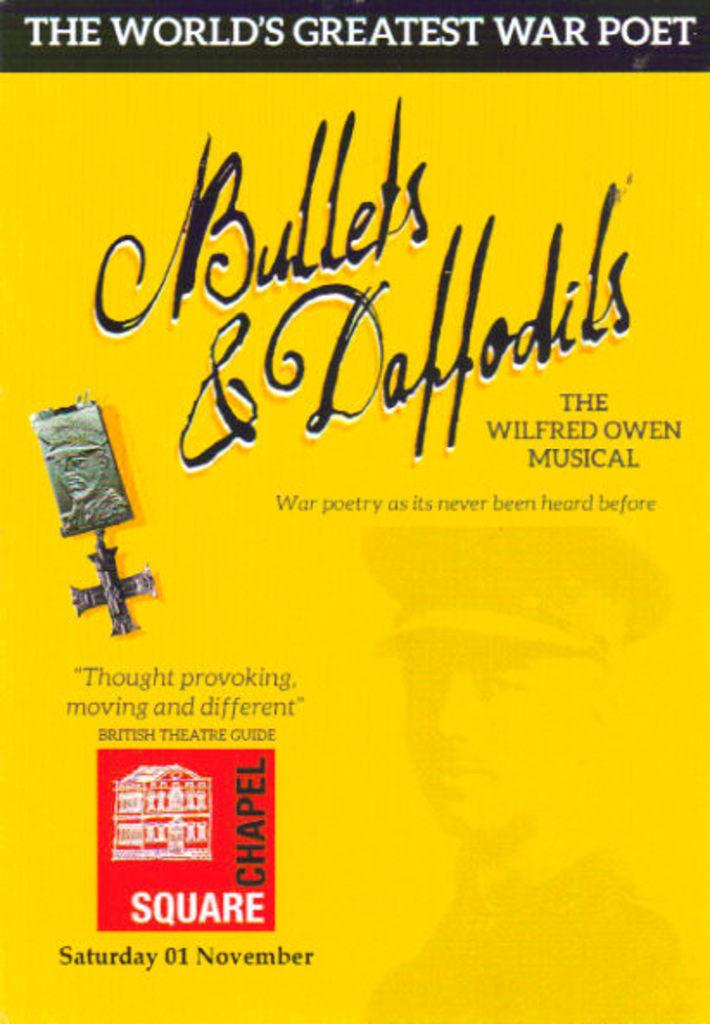Provide a one-sentence caption for the provided image. Book cover for Bullets & Daffodils and the saying "The World's Greatest War Poet" on top. 